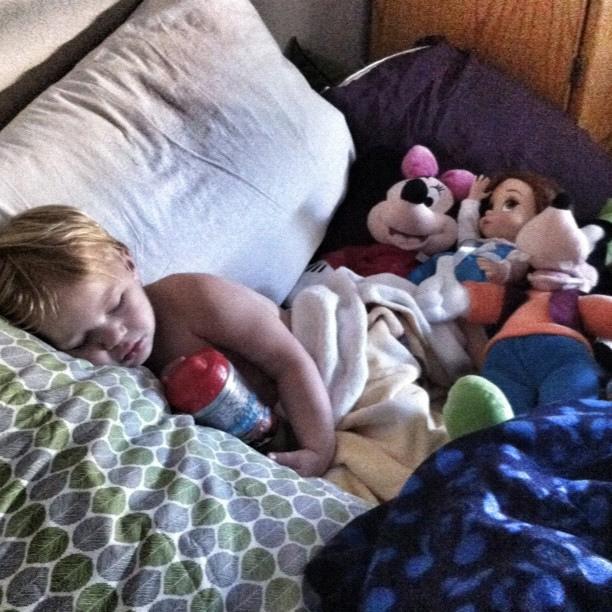In which one of these cities can you meet the characters shown here?
Make your selection from the four choices given to correctly answer the question.
Options: Fargo, hershey, trenton, anaheim. Anaheim. 